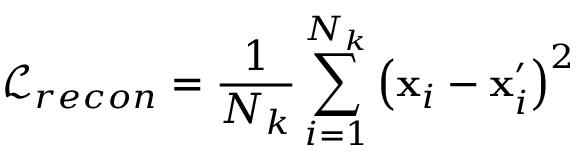Convert formula to latex. <formula><loc_0><loc_0><loc_500><loc_500>\mathcal { L } _ { r e c o n } = \frac { 1 } { N _ { k } } \sum _ { i = 1 } ^ { N _ { k } } \left ( x _ { i } - { x } _ { i } ^ { \prime } \right ) ^ { 2 }</formula> 